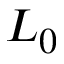Convert formula to latex. <formula><loc_0><loc_0><loc_500><loc_500>L _ { 0 }</formula> 